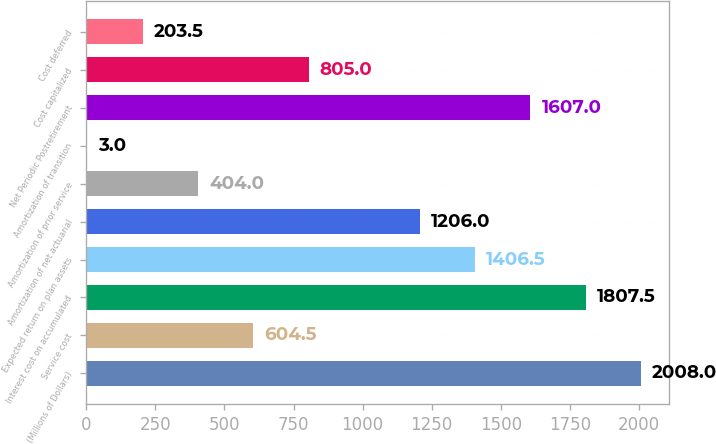Convert chart. <chart><loc_0><loc_0><loc_500><loc_500><bar_chart><fcel>(Millions of Dollars)<fcel>Service cost<fcel>Interest cost on accumulated<fcel>Expected return on plan assets<fcel>Amortization of net actuarial<fcel>Amortization of prior service<fcel>Amortization of transition<fcel>Net Periodic Postretirement<fcel>Cost capitalized<fcel>Cost deferred<nl><fcel>2008<fcel>604.5<fcel>1807.5<fcel>1406.5<fcel>1206<fcel>404<fcel>3<fcel>1607<fcel>805<fcel>203.5<nl></chart> 